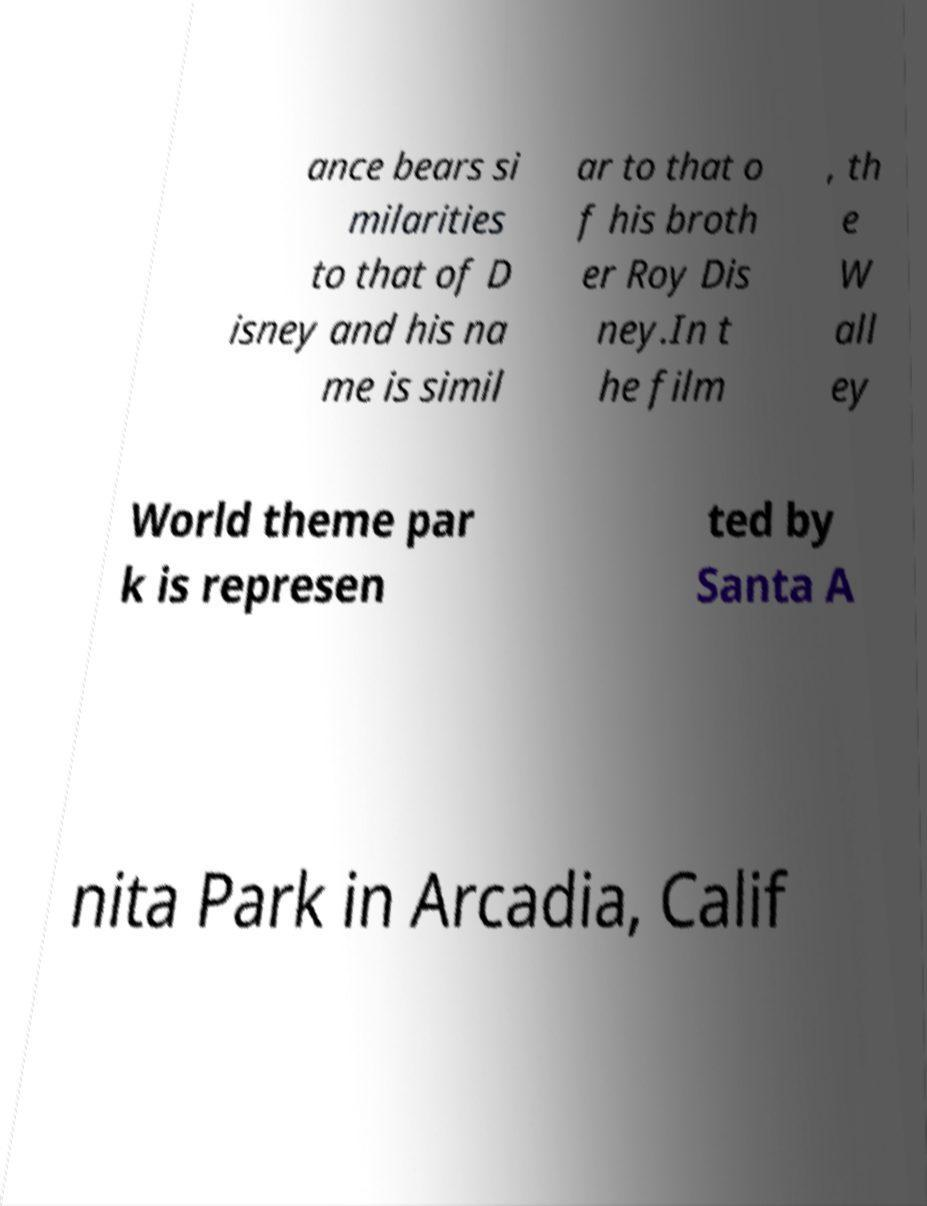There's text embedded in this image that I need extracted. Can you transcribe it verbatim? ance bears si milarities to that of D isney and his na me is simil ar to that o f his broth er Roy Dis ney.In t he film , th e W all ey World theme par k is represen ted by Santa A nita Park in Arcadia, Calif 